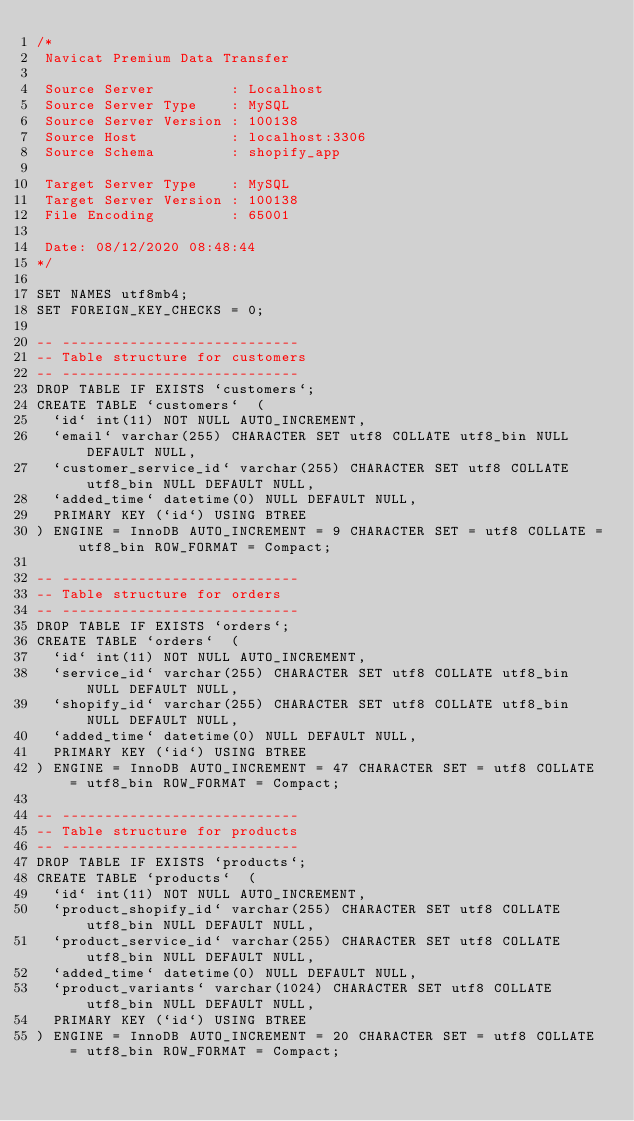Convert code to text. <code><loc_0><loc_0><loc_500><loc_500><_SQL_>/*
 Navicat Premium Data Transfer

 Source Server         : Localhost
 Source Server Type    : MySQL
 Source Server Version : 100138
 Source Host           : localhost:3306
 Source Schema         : shopify_app

 Target Server Type    : MySQL
 Target Server Version : 100138
 File Encoding         : 65001

 Date: 08/12/2020 08:48:44
*/

SET NAMES utf8mb4;
SET FOREIGN_KEY_CHECKS = 0;

-- ----------------------------
-- Table structure for customers
-- ----------------------------
DROP TABLE IF EXISTS `customers`;
CREATE TABLE `customers`  (
  `id` int(11) NOT NULL AUTO_INCREMENT,
  `email` varchar(255) CHARACTER SET utf8 COLLATE utf8_bin NULL DEFAULT NULL,
  `customer_service_id` varchar(255) CHARACTER SET utf8 COLLATE utf8_bin NULL DEFAULT NULL,
  `added_time` datetime(0) NULL DEFAULT NULL,
  PRIMARY KEY (`id`) USING BTREE
) ENGINE = InnoDB AUTO_INCREMENT = 9 CHARACTER SET = utf8 COLLATE = utf8_bin ROW_FORMAT = Compact;

-- ----------------------------
-- Table structure for orders
-- ----------------------------
DROP TABLE IF EXISTS `orders`;
CREATE TABLE `orders`  (
  `id` int(11) NOT NULL AUTO_INCREMENT,
  `service_id` varchar(255) CHARACTER SET utf8 COLLATE utf8_bin NULL DEFAULT NULL,
  `shopify_id` varchar(255) CHARACTER SET utf8 COLLATE utf8_bin NULL DEFAULT NULL,
  `added_time` datetime(0) NULL DEFAULT NULL,
  PRIMARY KEY (`id`) USING BTREE
) ENGINE = InnoDB AUTO_INCREMENT = 47 CHARACTER SET = utf8 COLLATE = utf8_bin ROW_FORMAT = Compact;

-- ----------------------------
-- Table structure for products
-- ----------------------------
DROP TABLE IF EXISTS `products`;
CREATE TABLE `products`  (
  `id` int(11) NOT NULL AUTO_INCREMENT,
  `product_shopify_id` varchar(255) CHARACTER SET utf8 COLLATE utf8_bin NULL DEFAULT NULL,
  `product_service_id` varchar(255) CHARACTER SET utf8 COLLATE utf8_bin NULL DEFAULT NULL,
  `added_time` datetime(0) NULL DEFAULT NULL,
  `product_variants` varchar(1024) CHARACTER SET utf8 COLLATE utf8_bin NULL DEFAULT NULL,
  PRIMARY KEY (`id`) USING BTREE
) ENGINE = InnoDB AUTO_INCREMENT = 20 CHARACTER SET = utf8 COLLATE = utf8_bin ROW_FORMAT = Compact;
</code> 